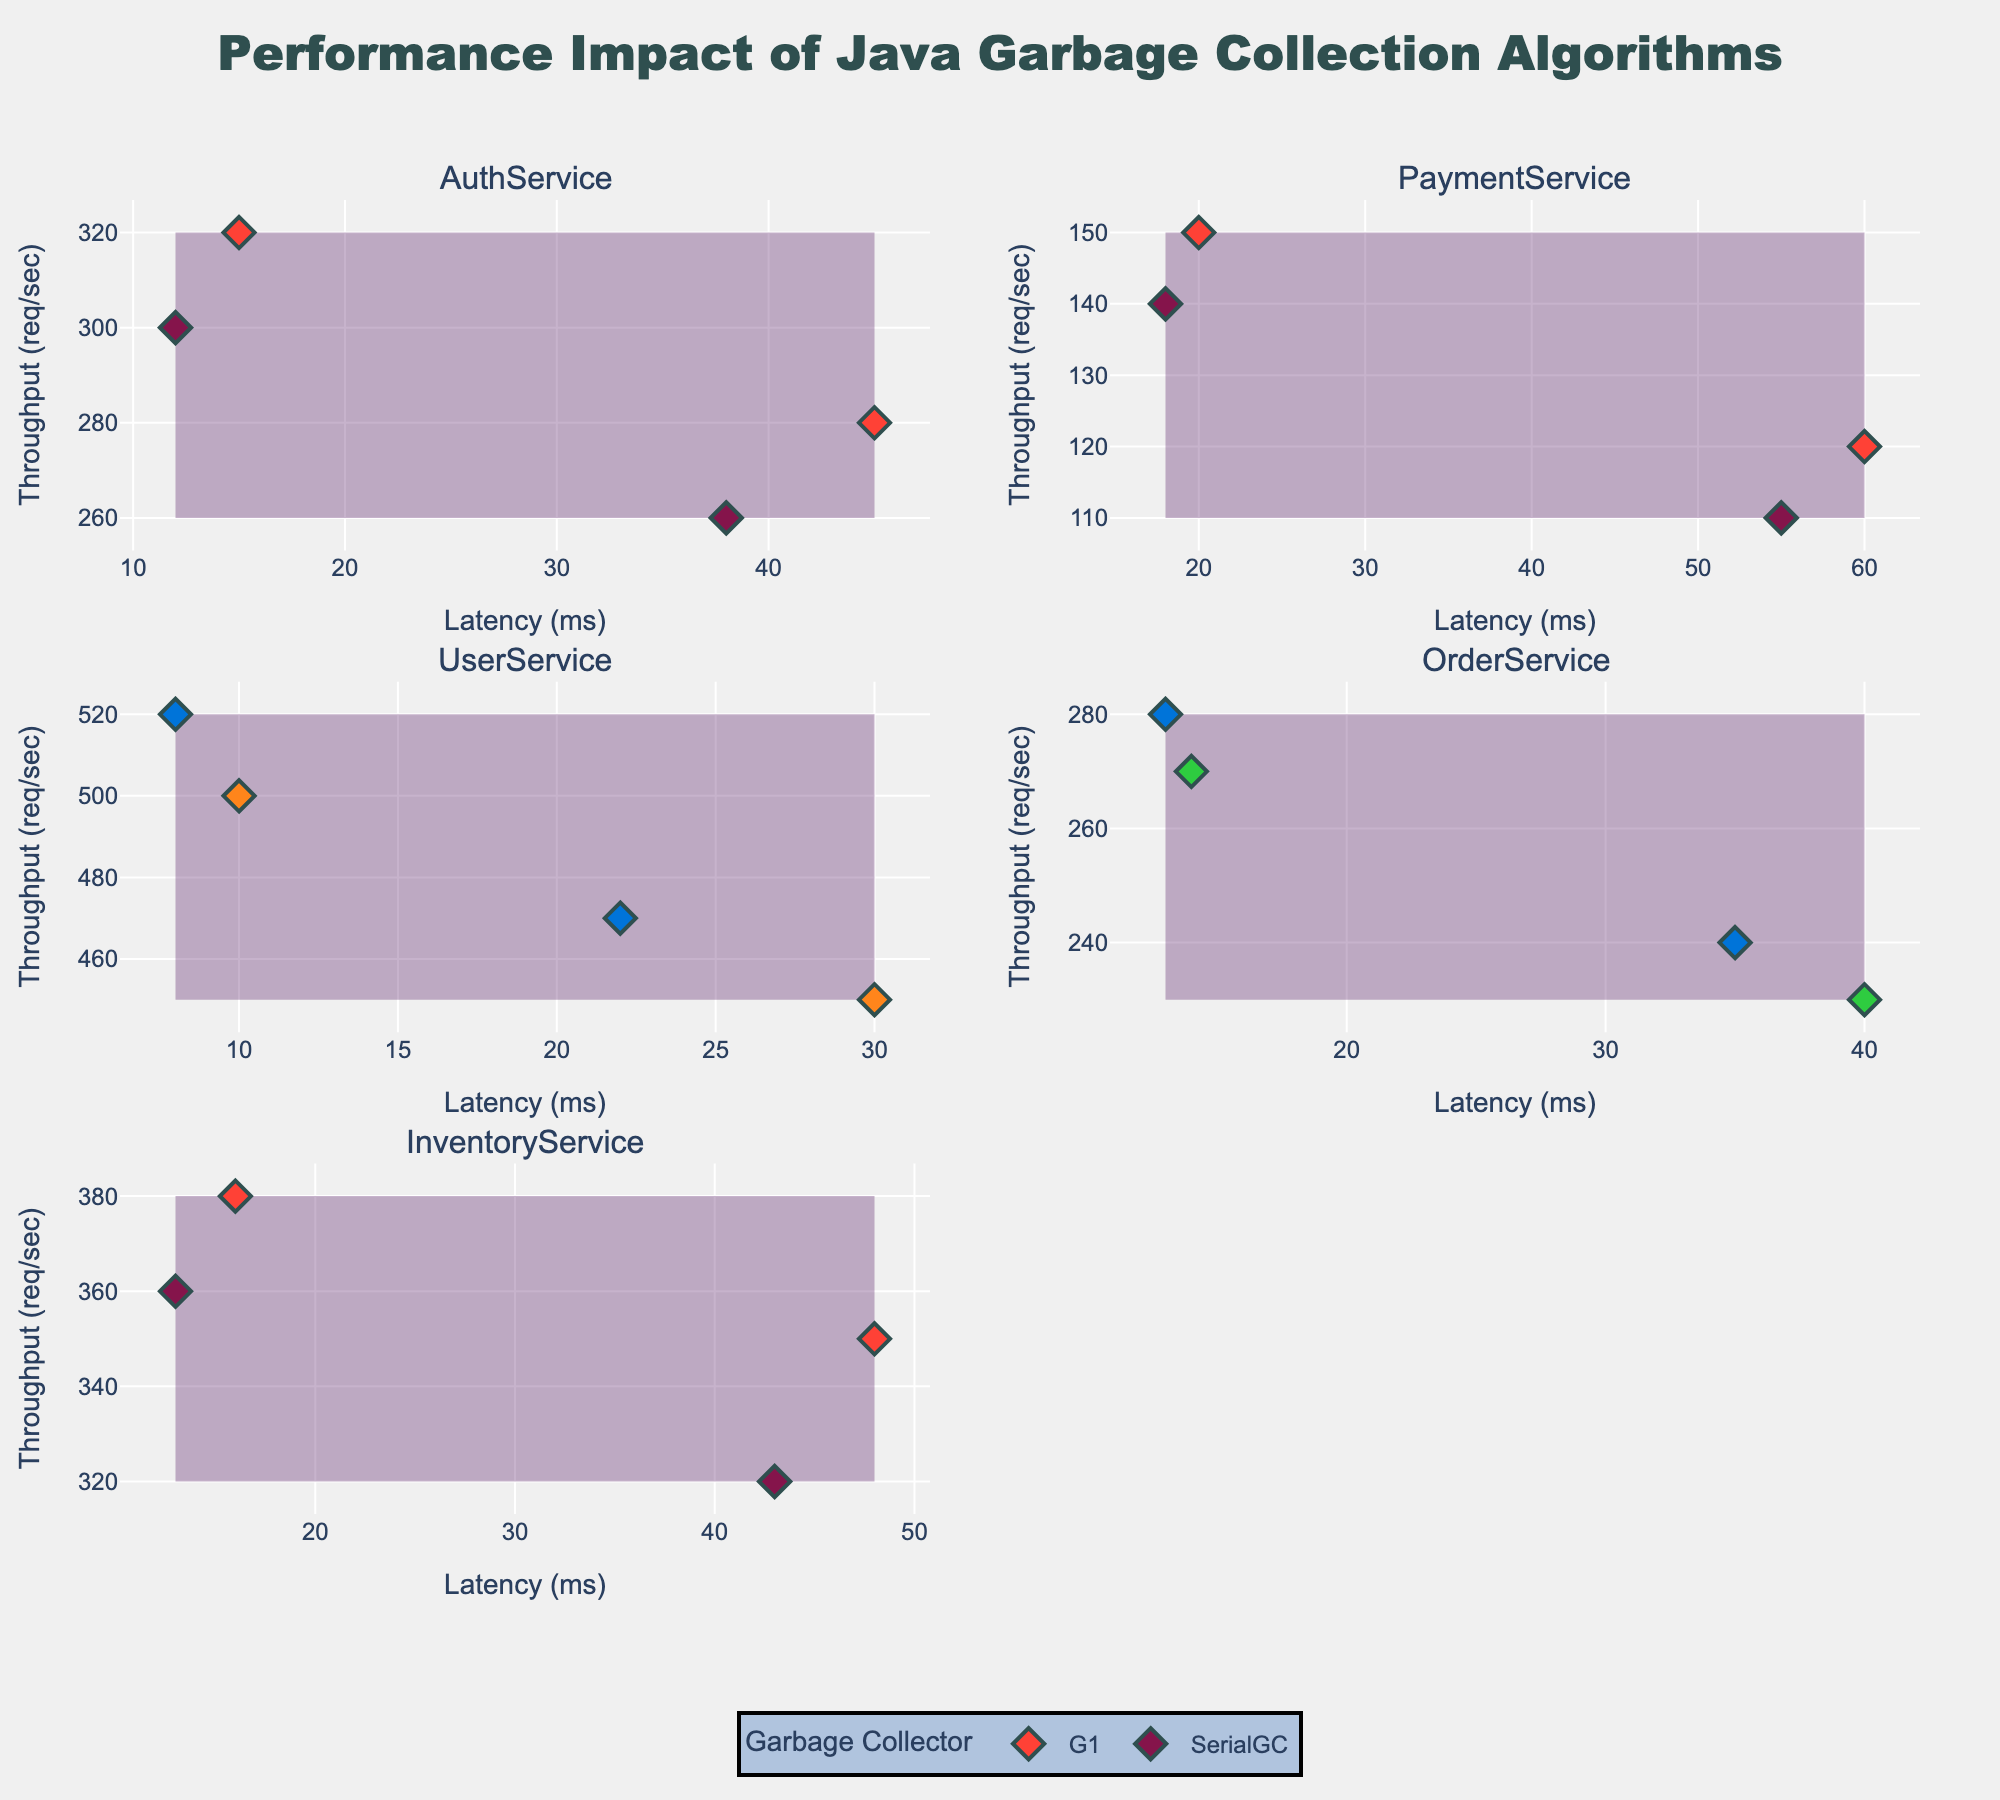What is the title of the chart? The title can be found at the very top of the chart. It reads: "Performance Impact of Java Garbage Collection Algorithms".
Answer: Performance Impact of Java Garbage Collection Algorithms Which service has the lowest latency for its best-performing garbage collector under low load? By inspecting each subplot, note the lowest latency values for each service under low load. UserService with ZGC under low load has the lowest latency of 8 ms.
Answer: UserService with ZGC Identify the garbage collector with the highest throughput for PaymentService under high load. Look at the PaymentService subplot and compare the throughput values under high load for different garbage collectors. G1 has the highest throughput of 120 req/sec.
Answer: G1 What’s the approximate latency range for OrderService with CMS garbage collector? Focusing on OrderService's subplot, examine the latency values for the CMS garbage collector. The range is from 14 ms (low load) to 40 ms (high load).
Answer: 14 – 40 ms Which service and garbage collector combination achieves the highest throughput overall, and what is the value? Scan all subplots for the highest throughput value. UserService with ZGC under low load achieves 520 req/sec.
Answer: UserService with ZGC, 520 req/sec Compare the latencies of SerialGC and G1 for AuthService under high load; which one is better? Referring to the AuthService subplot under high load, SerialGC has a lower latency of 38 ms compared to G1 which has 45 ms. Hence, SerialGC performs better.
Answer: SerialGC What is the difference in throughput for InventoryService between G1 and SerialGC under high load? For InventoryService, under high load, G1 has a throughput of 350 req/sec and SerialGC has 320 req/sec. The difference is calculated as 350 - 320.
Answer: 30 req/sec Which garbage collectors are used for UserService and how do their performances compare on throughput under high load? Look at UserService's subplot and identify the garbage collectors used (ParallelGC and ZGC). Under high load, ParallelGC has 450 req/sec and ZGC has 470 req/sec, so ZGC performs better in throughput.
Answer: ParallelGC and ZGC; ZGC performs better For PaymentService, which garbage collector has a lower latency under low load and by how much? Examine PaymentService's subplot for low load. G1 has a latency of 20 ms and SerialGC has 18 ms. The difference is 20 - 18.
Answer: SerialGC by 2 ms 